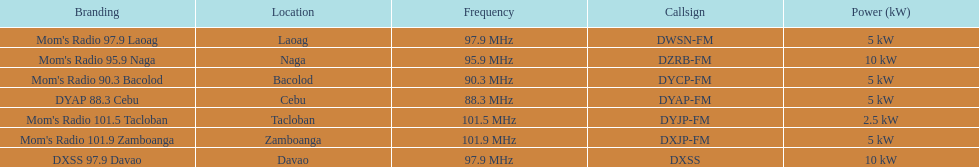I'm looking to parse the entire table for insights. Could you assist me with that? {'header': ['Branding', 'Location', 'Frequency', 'Callsign', 'Power (kW)'], 'rows': [["Mom's Radio 97.9 Laoag", 'Laoag', '97.9\xa0MHz', 'DWSN-FM', '5\xa0kW'], ["Mom's Radio 95.9 Naga", 'Naga', '95.9\xa0MHz', 'DZRB-FM', '10\xa0kW'], ["Mom's Radio 90.3 Bacolod", 'Bacolod', '90.3\xa0MHz', 'DYCP-FM', '5\xa0kW'], ['DYAP 88.3 Cebu', 'Cebu', '88.3\xa0MHz', 'DYAP-FM', '5\xa0kW'], ["Mom's Radio 101.5 Tacloban", 'Tacloban', '101.5\xa0MHz', 'DYJP-FM', '2.5\xa0kW'], ["Mom's Radio 101.9 Zamboanga", 'Zamboanga', '101.9\xa0MHz', 'DXJP-FM', '5\xa0kW'], ['DXSS 97.9 Davao', 'Davao', '97.9\xa0MHz', 'DXSS', '10\xa0kW']]} How many kw was the radio in davao? 10 kW. 